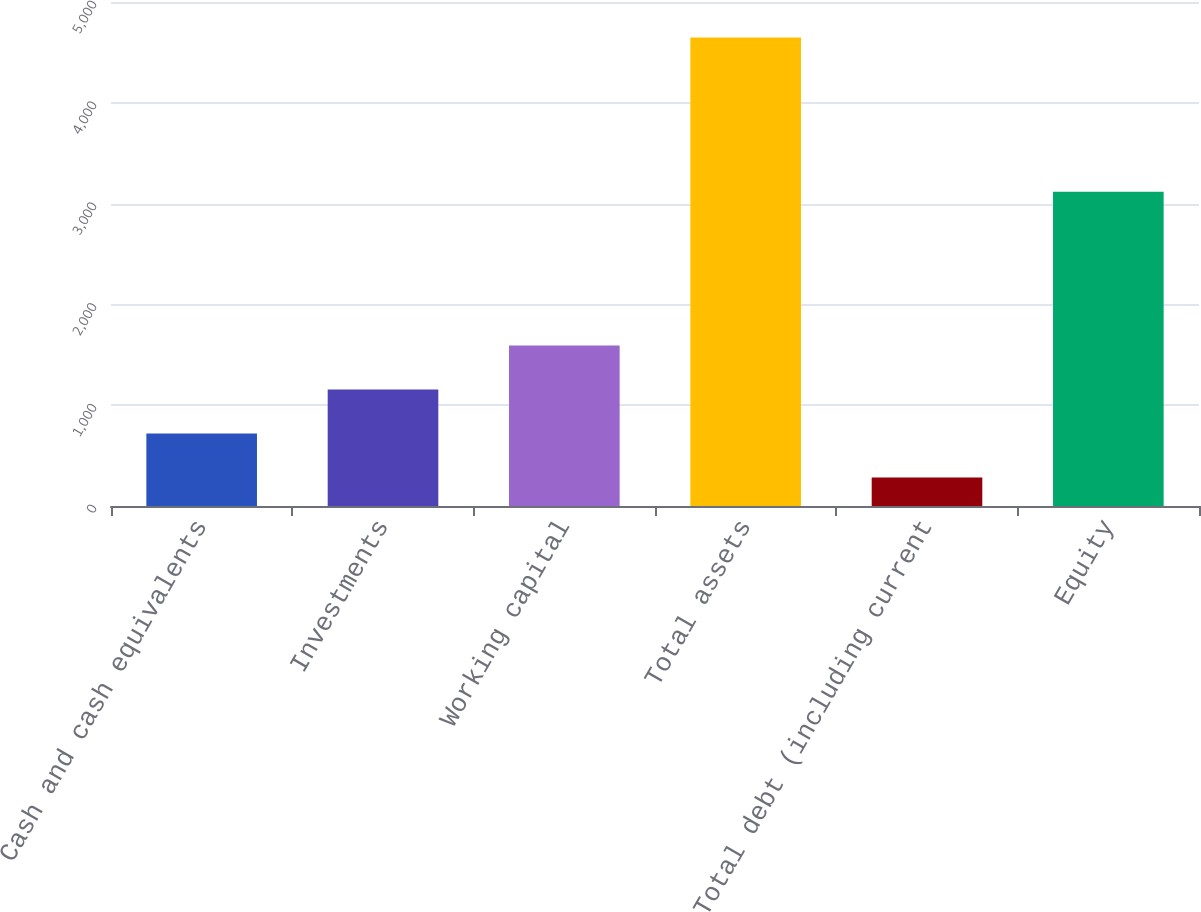<chart> <loc_0><loc_0><loc_500><loc_500><bar_chart><fcel>Cash and cash equivalents<fcel>Investments<fcel>Working capital<fcel>Total assets<fcel>Total debt (including current<fcel>Equity<nl><fcel>718.7<fcel>1155.4<fcel>1592.1<fcel>4649<fcel>282<fcel>3117<nl></chart> 